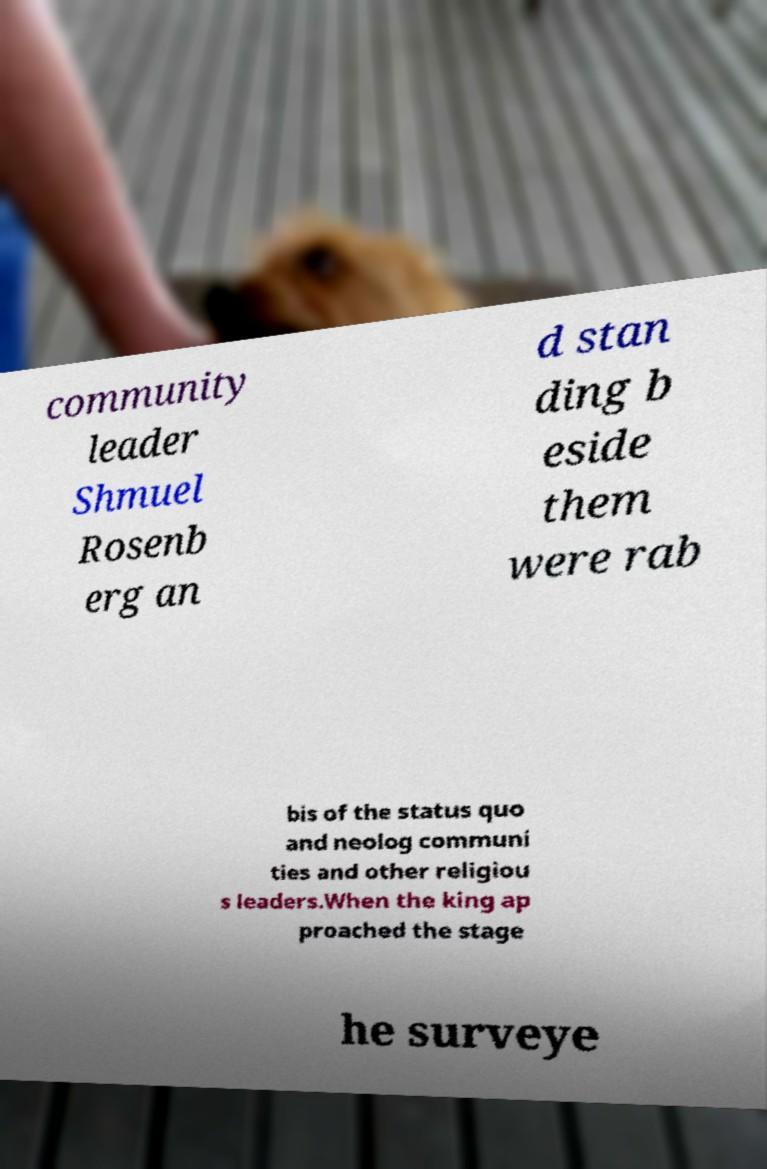Please read and relay the text visible in this image. What does it say? community leader Shmuel Rosenb erg an d stan ding b eside them were rab bis of the status quo and neolog communi ties and other religiou s leaders.When the king ap proached the stage he surveye 